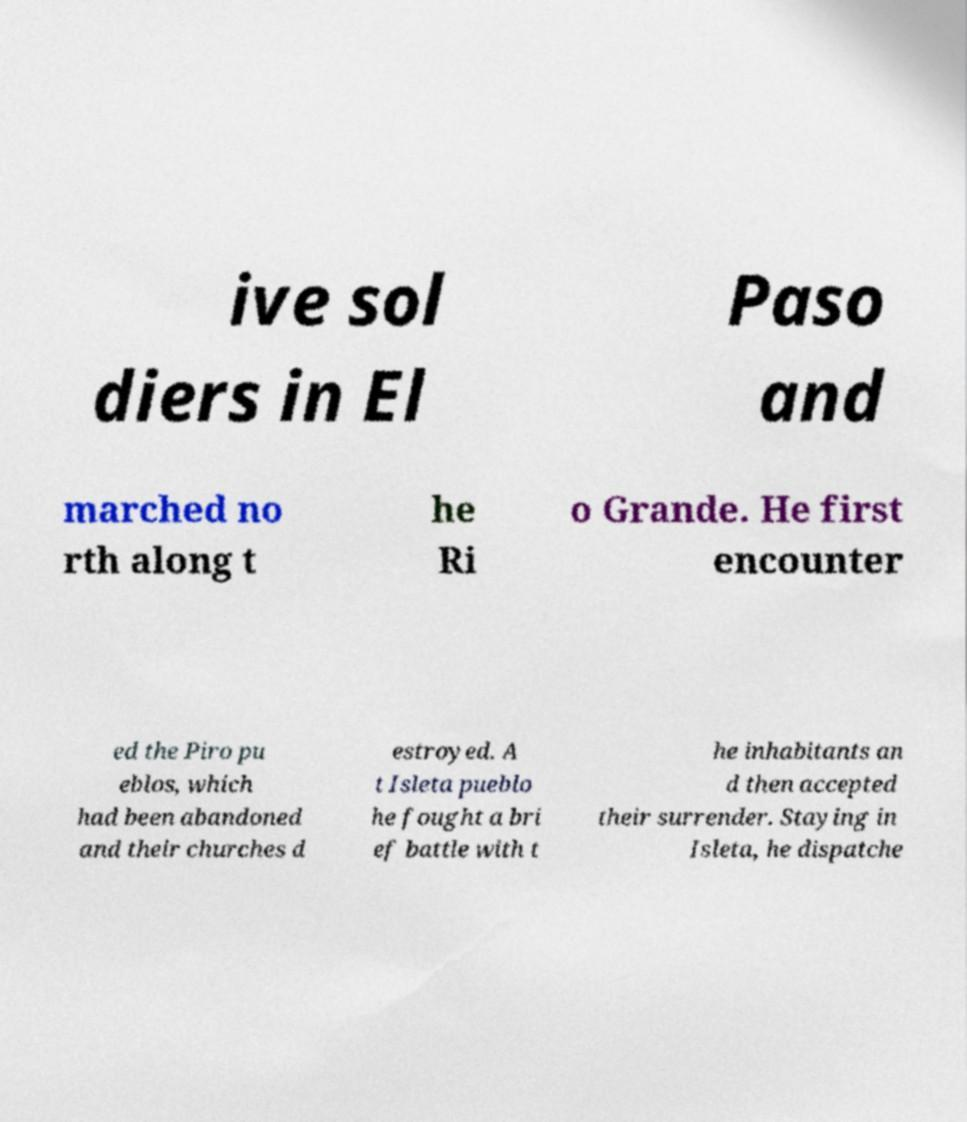What messages or text are displayed in this image? I need them in a readable, typed format. ive sol diers in El Paso and marched no rth along t he Ri o Grande. He first encounter ed the Piro pu eblos, which had been abandoned and their churches d estroyed. A t Isleta pueblo he fought a bri ef battle with t he inhabitants an d then accepted their surrender. Staying in Isleta, he dispatche 